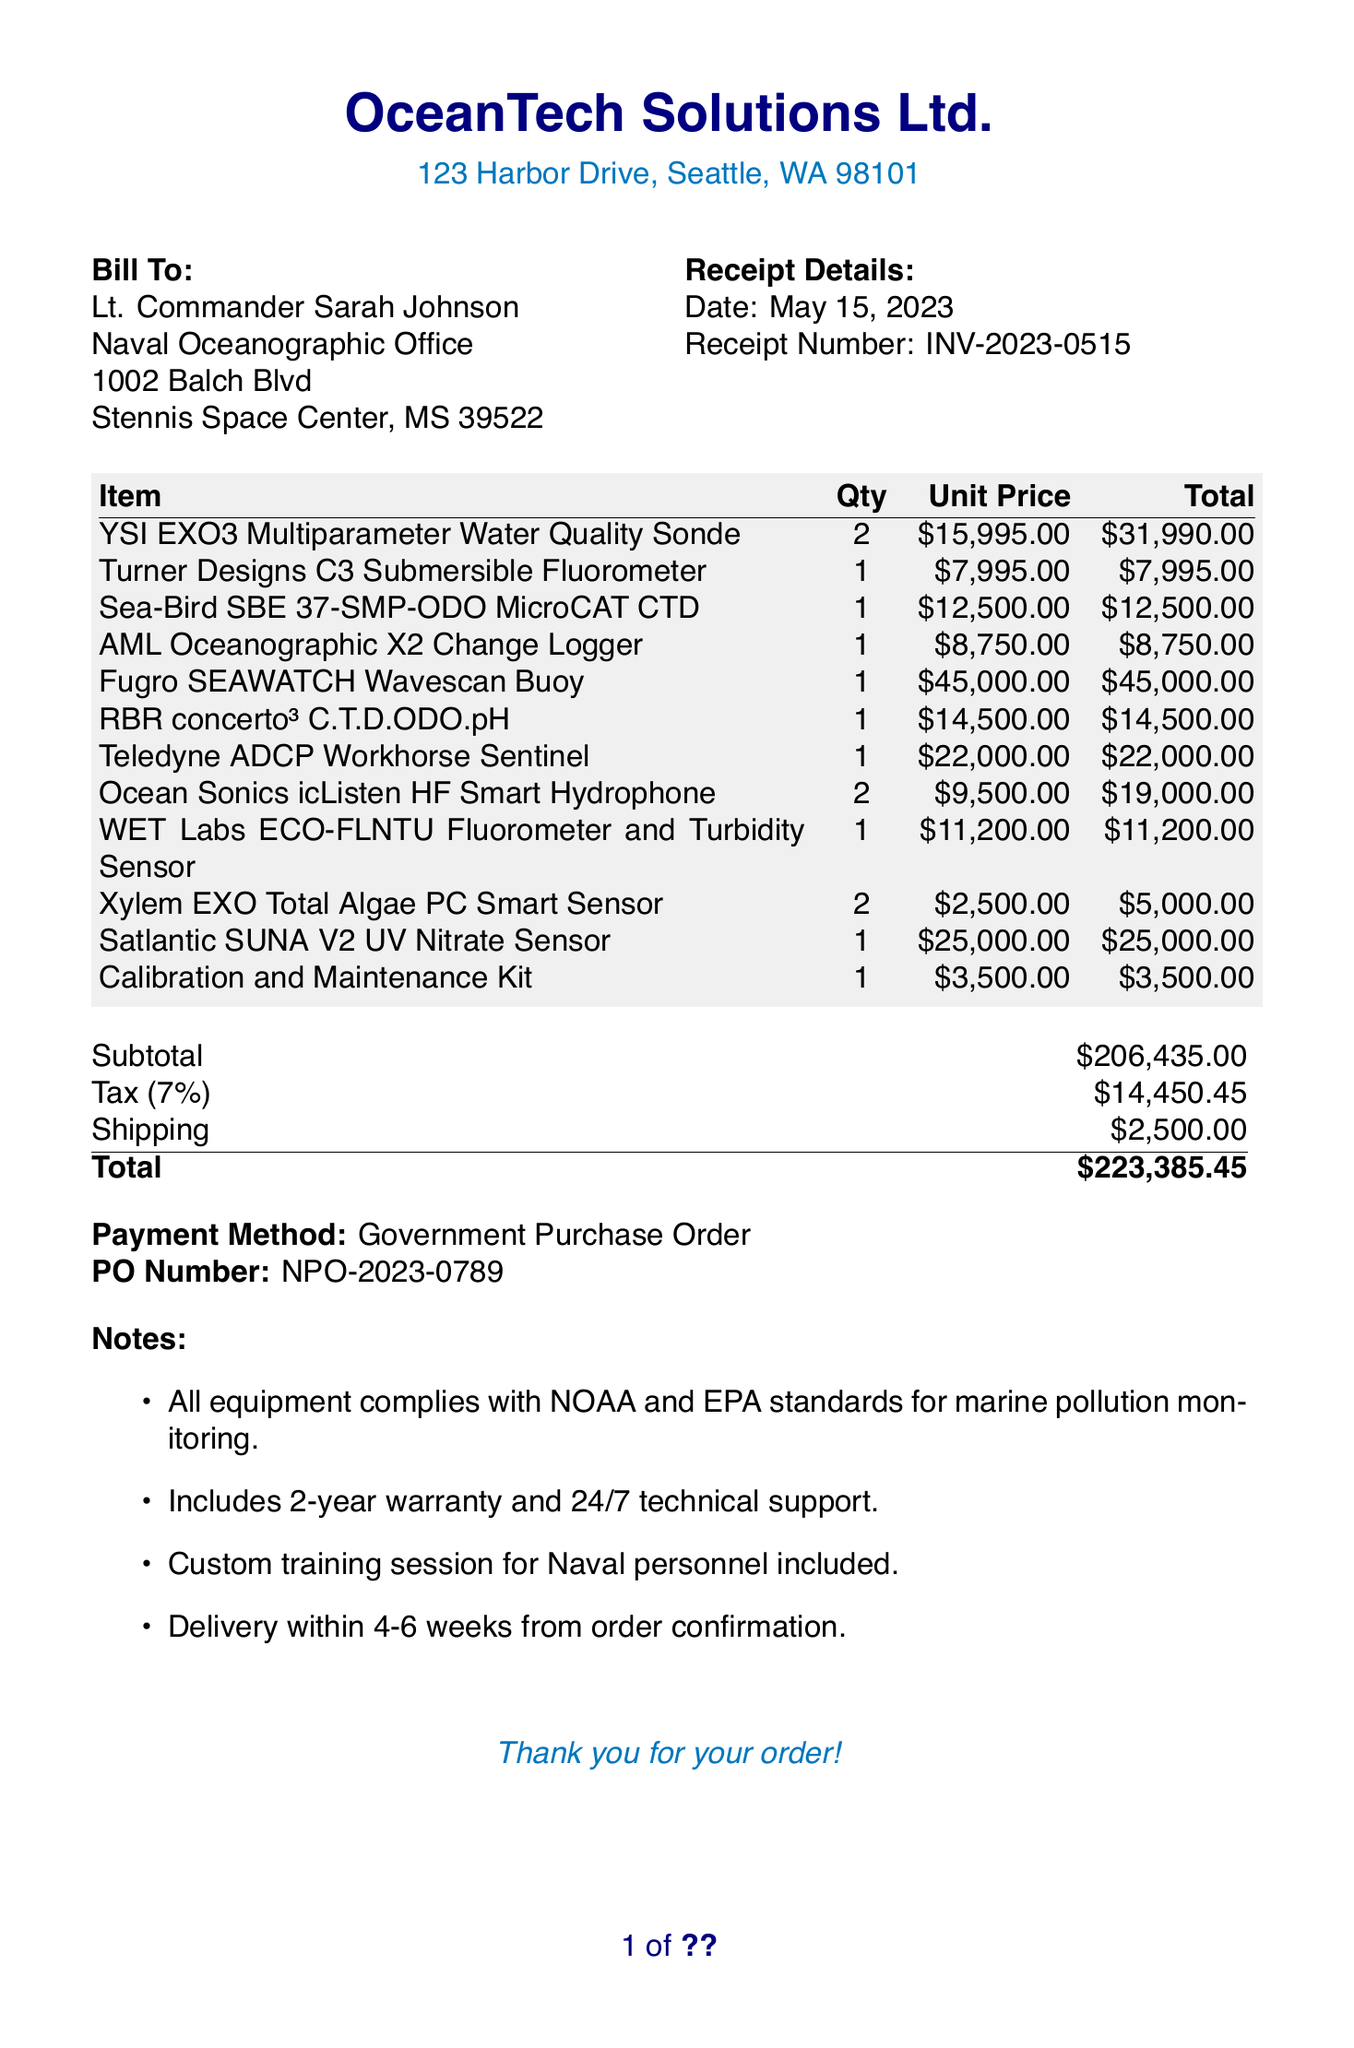What is the vendor's name? The vendor's name is listed at the top of the receipt.
Answer: OceanTech Solutions Ltd What is the total amount due? The total amount is calculated at the bottom of the receipt, including all items, tax, and shipping.
Answer: $223,385.45 How many items were purchased in total? The receipt lists multiple items purchased with quantities provided for each.
Answer: 12 What is the customer’s address? The customer’s address is stated in the bill-to section.
Answer: Naval Oceanographic Office, 1002 Balch Blvd, Stennis Space Center, MS 39522 What is the date of the receipt? The date is indicated in the receipt details section.
Answer: May 15, 2023 How much was spent on the YSI EXO3 Multi-parameter Water Quality Sonde? This item's total cost is detailed under the items section.
Answer: $31,990.00 What payment method was used? The payment method is mentioned near the end of the receipt.
Answer: Government Purchase Order What is the tax rate applied to the subtotal? The tax rate is indicated in the additional details section of the receipt.
Answer: 7% What kind of warranty is included with the equipment? The notes section describes the warranty provided with the equipment.
Answer: 2-year warranty How long will it take for delivery? The delivery timeframe is mentioned in the notes section of the receipt.
Answer: 4-6 weeks 